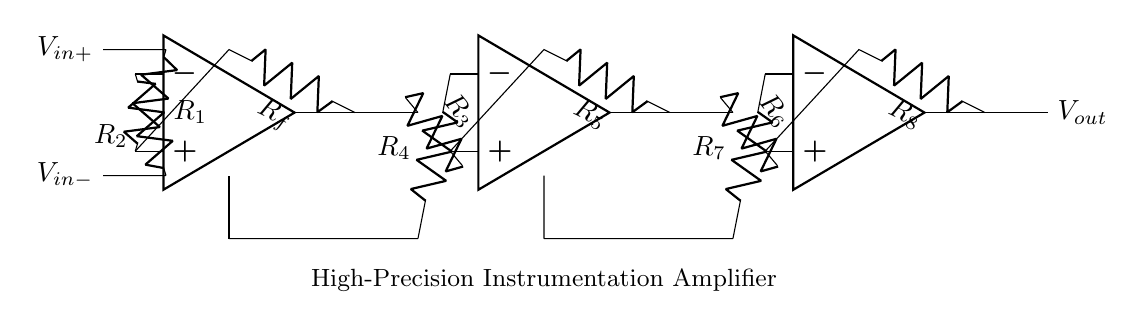What is the type of amplifier used in this circuit? The circuit employs operational amplifiers, indicating that it is an instrumentation amplifier, specifically designed for high precision.
Answer: instrumentation amplifier What are the resistance values in this circuit? The circuit contains several resistors labeled as R1, R2, R3, R4, R5, R6, R7, and R8, each contributing to the amplifier's gain and stability.
Answer: R1, R2, R3, R4, R5, R6, R7, R8 How many operational amplifiers are in this circuit? The diagram indicates three operational amplifiers arranged in sequence, which are crucial for achieving high gain and reducing noise.
Answer: three What is the purpose of resistors R_f in this circuit? Resistor R_f is used to provide negative feedback for the first operational amplifier, stabilizing the gain and improving linear response.
Answer: feedback What can be inferred about the input signals of this instrumentation amplifier? The circuit has two input signals, V_in+ and V_in-, suggesting that it is designed to amplify the difference between these two voltages while rejecting common-mode signals.
Answer: differential input How does this circuit enhance precision in measurements? By utilizing multiple op-amps and precise resistor values, this configuration minimizes offset errors and increases common-mode rejection, which is essential for sensitive laboratory measurements.
Answer: high precision 